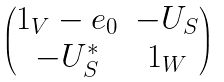Convert formula to latex. <formula><loc_0><loc_0><loc_500><loc_500>\begin{pmatrix} 1 _ { V } - e _ { 0 } & - U _ { S } \\ - U _ { S } ^ { * } & 1 _ { W } \end{pmatrix}</formula> 